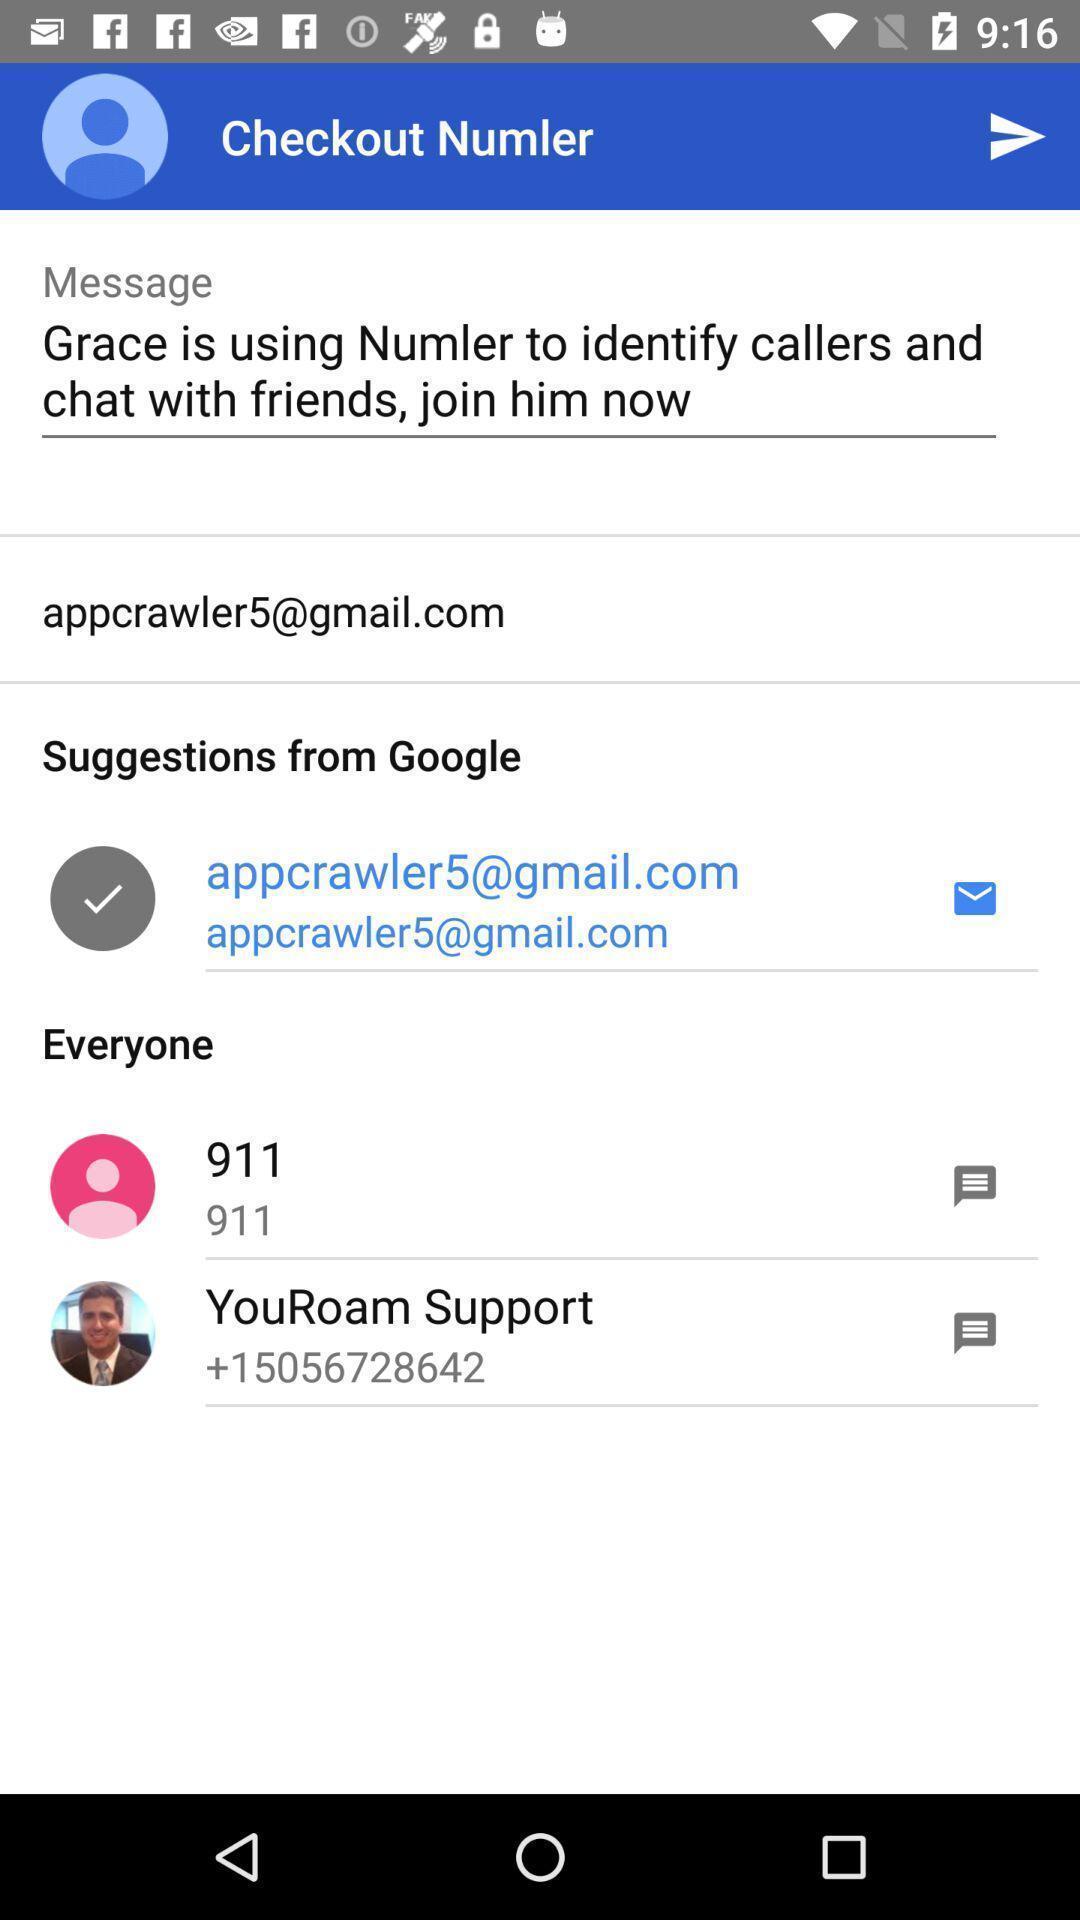Tell me about the visual elements in this screen capture. Screen displaying screen page. 